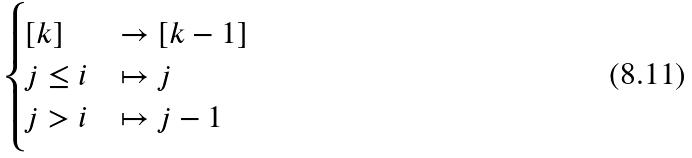Convert formula to latex. <formula><loc_0><loc_0><loc_500><loc_500>\begin{cases} [ k ] & \rightarrow [ k - 1 ] \\ j \leq i & \mapsto j \\ j > i & \mapsto j - 1 \end{cases}</formula> 